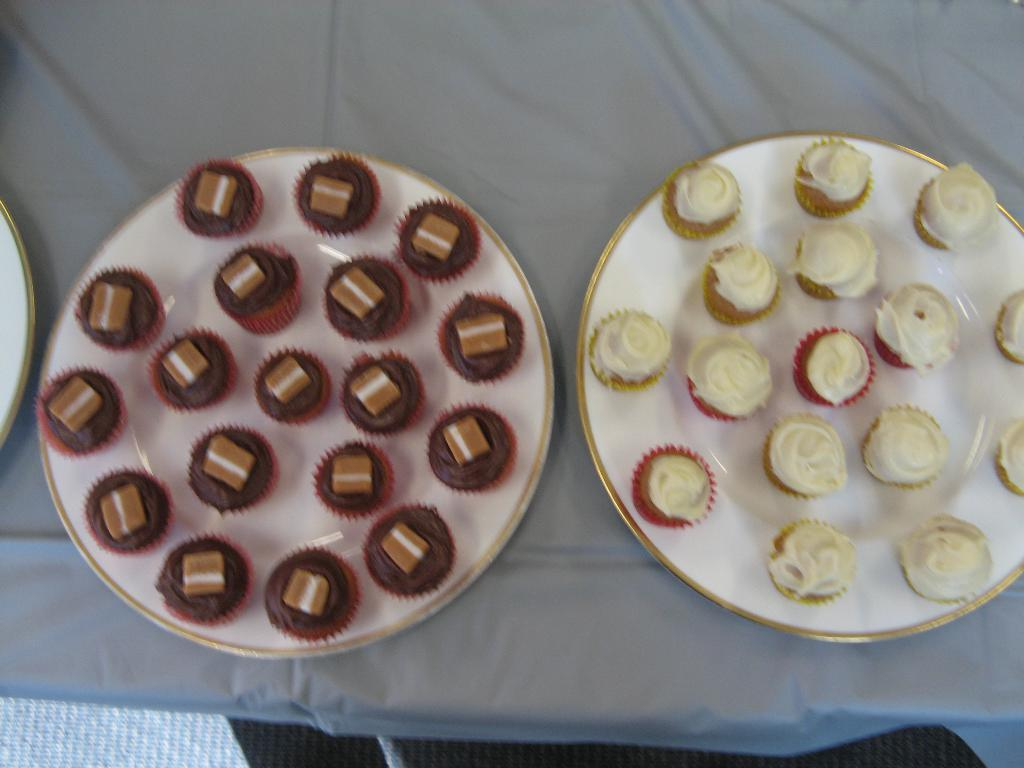What type of food is shown in the image? There are cupcakes in the image. How are the cupcakes arranged? The cupcakes are on two plates. Can you describe the possible location of the plates? The plates might be on a table. What type of development can be seen in the image? There is no development visible in the image; it features cupcakes on plates. Is there any rain present in the image? There is no rain present in the image; it is a still image of cupcakes on plates. 